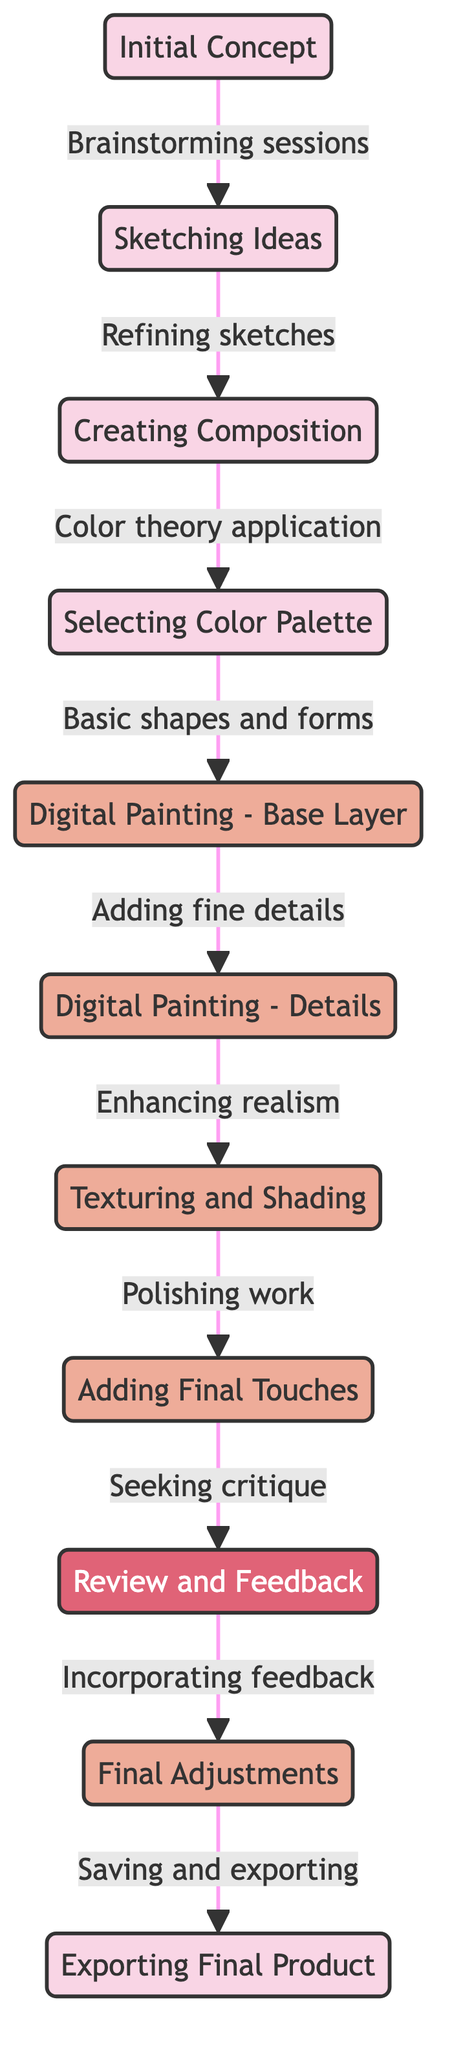What is the first step in the digital art creation workflow? The diagram indicates that the first node is "Initial Concept," which is the starting point of the workflow.
Answer: Initial Concept How many total nodes are in the diagram? Counting the nodes listed in the diagram, there are 11 distinct steps in the digital art creation process.
Answer: 11 What process follows "Digital Painting - Base Layer"? According to the connections in the diagram, the step following "Digital Painting - Base Layer" is "Digital Painting - Details," which adds more intricate elements to the artwork.
Answer: Digital Painting - Details What step involves "Seeking critique"? The diagram shows that "Review and Feedback" is the step where critique is sought from others, allowing for improvements based on external input.
Answer: Review and Feedback What is the link from "Sketching Ideas" to "Creating Composition"? The edge from "Sketching Ideas" to "Creating Composition" is labeled "Refining sketches," indicating this is the transition between these two stages.
Answer: Refining sketches What is the last step before exporting the final product? The diagram indicates that "Final Adjustments" occurs immediately before "Exporting Final Product," ensuring the artwork is polished for presentation.
Answer: Final Adjustments Which step includes "Polishing work"? The diagram clearly connects "Texturing and Shading" to the step of "Adding Final Touches," where the artist finishes their piece with further refinements.
Answer: Adding Final Touches What role does "Incorporating feedback" play in the workflow? "Incorporating feedback" follows "Review and Feedback," showing its importance in the workflow for making revisions based on critiques received.
Answer: Incorporating feedback 